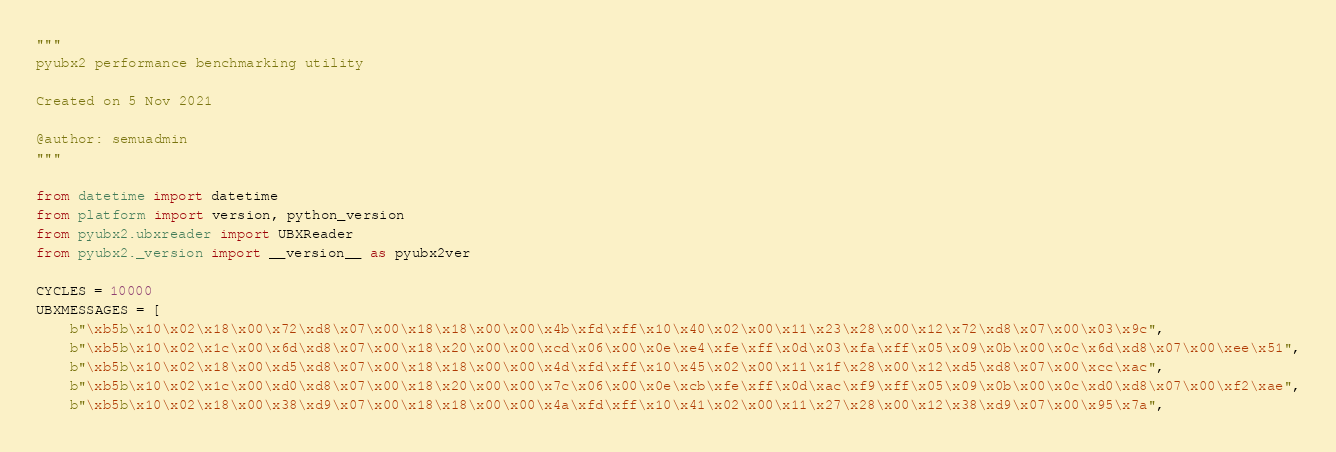Convert code to text. <code><loc_0><loc_0><loc_500><loc_500><_Python_>"""
pyubx2 performance benchmarking utility

Created on 5 Nov 2021

@author: semuadmin
"""

from datetime import datetime
from platform import version, python_version
from pyubx2.ubxreader import UBXReader
from pyubx2._version import __version__ as pyubx2ver

CYCLES = 10000
UBXMESSAGES = [
    b"\xb5b\x10\x02\x18\x00\x72\xd8\x07\x00\x18\x18\x00\x00\x4b\xfd\xff\x10\x40\x02\x00\x11\x23\x28\x00\x12\x72\xd8\x07\x00\x03\x9c",
    b"\xb5b\x10\x02\x1c\x00\x6d\xd8\x07\x00\x18\x20\x00\x00\xcd\x06\x00\x0e\xe4\xfe\xff\x0d\x03\xfa\xff\x05\x09\x0b\x00\x0c\x6d\xd8\x07\x00\xee\x51",
    b"\xb5b\x10\x02\x18\x00\xd5\xd8\x07\x00\x18\x18\x00\x00\x4d\xfd\xff\x10\x45\x02\x00\x11\x1f\x28\x00\x12\xd5\xd8\x07\x00\xcc\xac",
    b"\xb5b\x10\x02\x1c\x00\xd0\xd8\x07\x00\x18\x20\x00\x00\x7c\x06\x00\x0e\xcb\xfe\xff\x0d\xac\xf9\xff\x05\x09\x0b\x00\x0c\xd0\xd8\x07\x00\xf2\xae",
    b"\xb5b\x10\x02\x18\x00\x38\xd9\x07\x00\x18\x18\x00\x00\x4a\xfd\xff\x10\x41\x02\x00\x11\x27\x28\x00\x12\x38\xd9\x07\x00\x95\x7a",</code> 